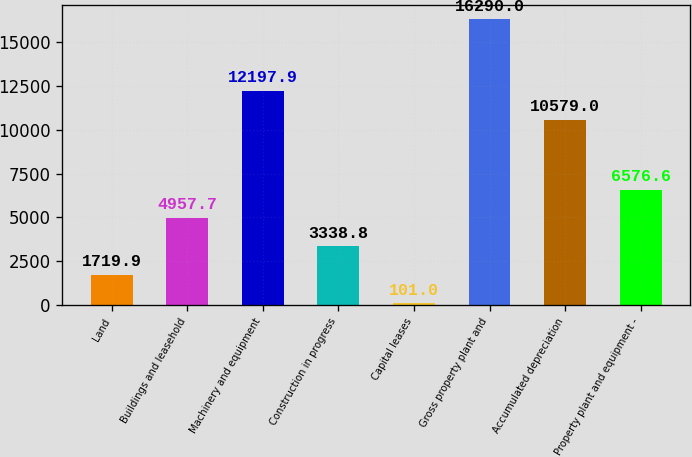Convert chart to OTSL. <chart><loc_0><loc_0><loc_500><loc_500><bar_chart><fcel>Land<fcel>Buildings and leasehold<fcel>Machinery and equipment<fcel>Construction in progress<fcel>Capital leases<fcel>Gross property plant and<fcel>Accumulated depreciation<fcel>Property plant and equipment -<nl><fcel>1719.9<fcel>4957.7<fcel>12197.9<fcel>3338.8<fcel>101<fcel>16290<fcel>10579<fcel>6576.6<nl></chart> 